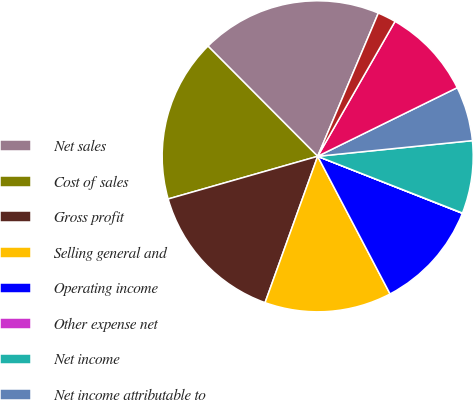<chart> <loc_0><loc_0><loc_500><loc_500><pie_chart><fcel>Net sales<fcel>Cost of sales<fcel>Gross profit<fcel>Selling general and<fcel>Operating income<fcel>Other expense net<fcel>Net income<fcel>Net income attributable to<fcel>Net cash provided by operating<fcel>Net cash used in investing<nl><fcel>18.84%<fcel>16.96%<fcel>15.08%<fcel>13.2%<fcel>11.32%<fcel>0.03%<fcel>7.55%<fcel>5.67%<fcel>9.44%<fcel>1.91%<nl></chart> 